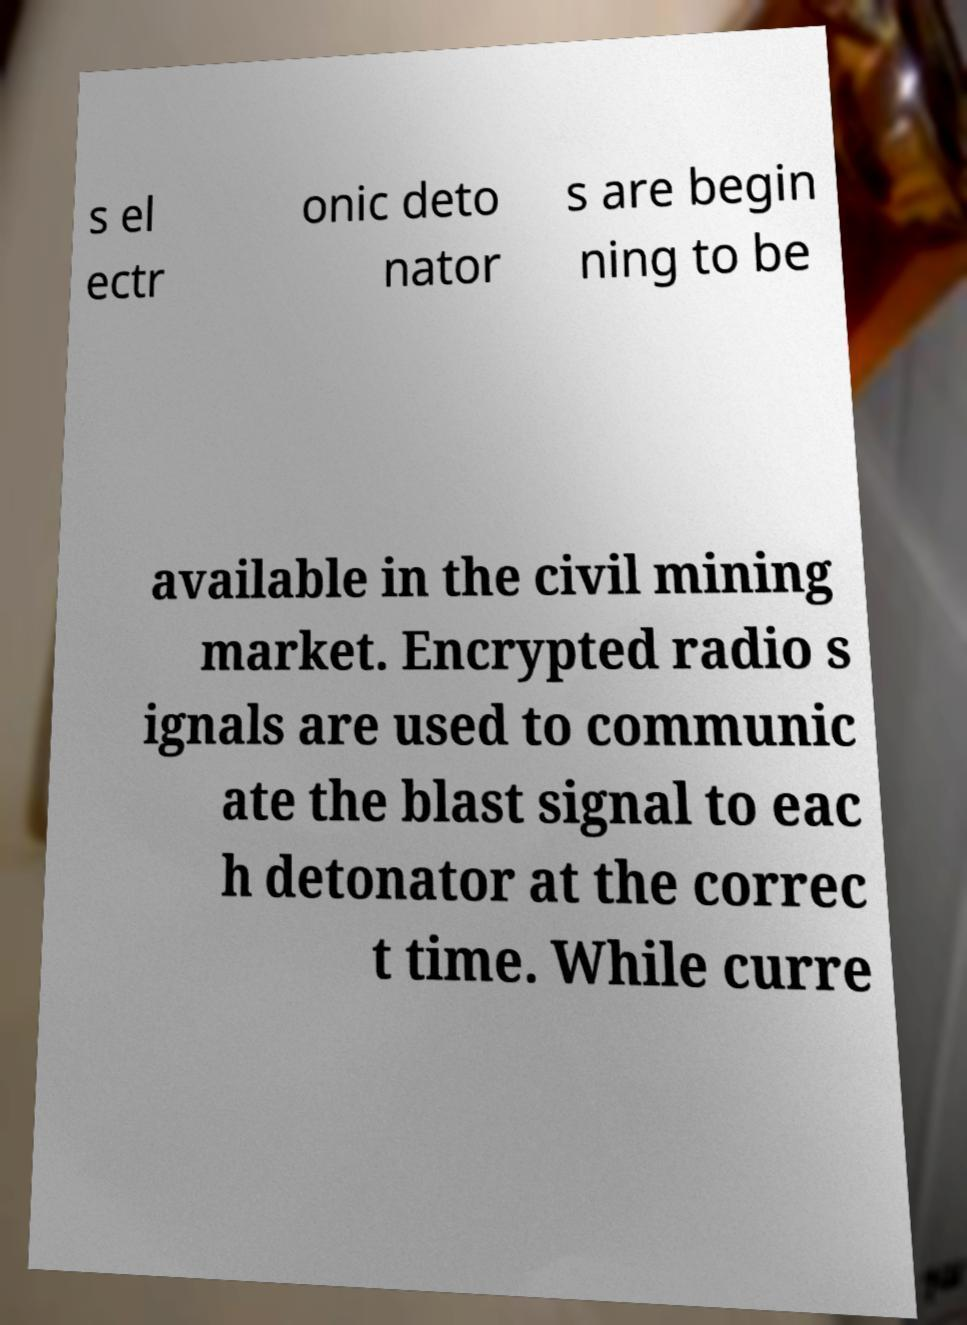Can you accurately transcribe the text from the provided image for me? s el ectr onic deto nator s are begin ning to be available in the civil mining market. Encrypted radio s ignals are used to communic ate the blast signal to eac h detonator at the correc t time. While curre 